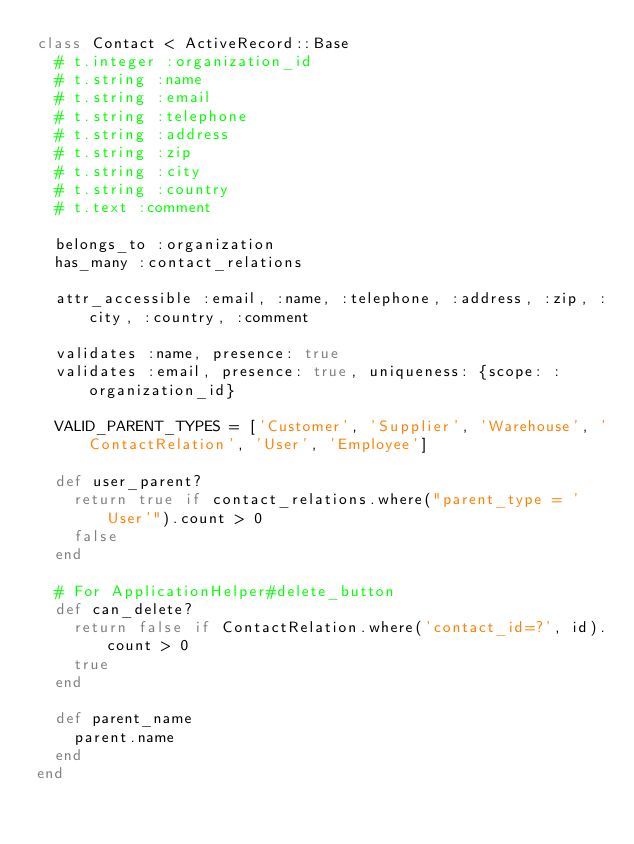Convert code to text. <code><loc_0><loc_0><loc_500><loc_500><_Ruby_>class Contact < ActiveRecord::Base
  # t.integer :organization_id
  # t.string :name
  # t.string :email
  # t.string :telephone
  # t.string :address
  # t.string :zip
  # t.string :city
  # t.string :country
  # t.text :comment

  belongs_to :organization
  has_many :contact_relations

  attr_accessible :email, :name, :telephone, :address, :zip, :city, :country, :comment

  validates :name, presence: true
  validates :email, presence: true, uniqueness: {scope: :organization_id}

  VALID_PARENT_TYPES = ['Customer', 'Supplier', 'Warehouse', 'ContactRelation', 'User', 'Employee']

  def user_parent?
    return true if contact_relations.where("parent_type = 'User'").count > 0
    false
  end

  # For ApplicationHelper#delete_button
  def can_delete?
    return false if ContactRelation.where('contact_id=?', id).count > 0
    true
  end

  def parent_name
    parent.name
  end
end
</code> 